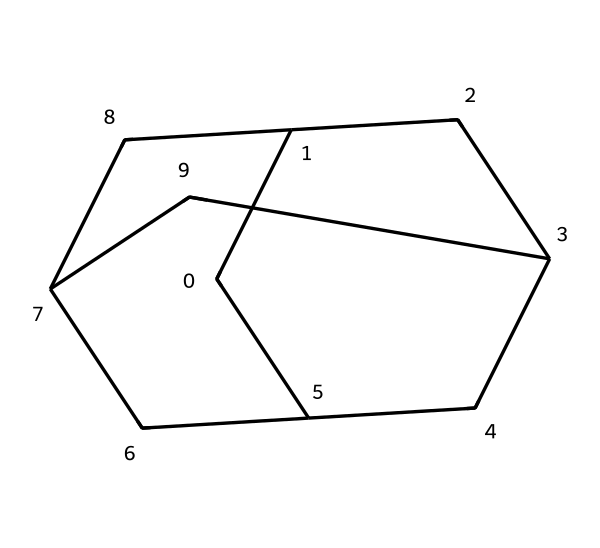What is the name of the chemical represented by this structure? The SMILES representation corresponds to adamantane, which is a well-known cage compound. The structural formula reveals its unique cage-like arrangement.
Answer: adamantane How many carbon atoms are present in adamantane? Analyzing the structure, there are 10 carbon atoms, as seen in the SMILES where 'C' appears multiple times without any other elements interrupting the carbon chain.
Answer: 10 How many hydrogen atoms are associated with adamantane? Using the formula for saturated hydrocarbons CnH2n+2, here n=10, leading to 2(10)+2 = 22 hydrogen atoms connected to the carbon framework seen in the structure.
Answer: 22 What type of hybridization do the carbon atoms in adamantane undergo? Each carbon in adamantane is connected to four other atoms (either carbon or hydrogen), indicating sp3 hybridization as it forms four sigma bonds, typical for saturated compounds.
Answer: sp3 What type of bonds are present in adamantane? The analysis of the structure shows that all the bonds formed between the carbon and hydrogen atoms are single covalent bonds, indicating saturation and stability typical for cage compounds.
Answer: single bonds What is one application of adamantane in technology? Its cage-like structure provides stability and unique properties, making it useful in high-tech coatings for electronic devices due to its durability and chemical resistance.
Answer: high-tech coatings 